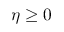<formula> <loc_0><loc_0><loc_500><loc_500>\eta \geq 0</formula> 